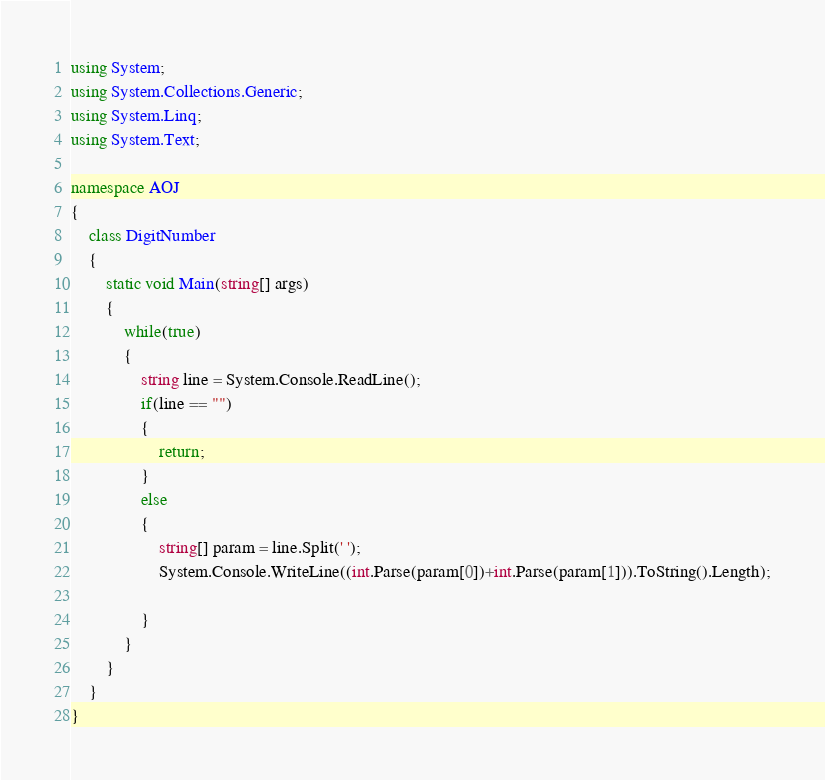<code> <loc_0><loc_0><loc_500><loc_500><_C#_>using System;
using System.Collections.Generic;
using System.Linq;
using System.Text;

namespace AOJ
{
    class DigitNumber
    {
        static void Main(string[] args)
        {
            while(true)
            {
                string line = System.Console.ReadLine();
                if(line == "")
                {
                    return;
                }
                else
                {
                    string[] param = line.Split(' ');
                    System.Console.WriteLine((int.Parse(param[0])+int.Parse(param[1])).ToString().Length);

                }
            }
        }
    }
}</code> 